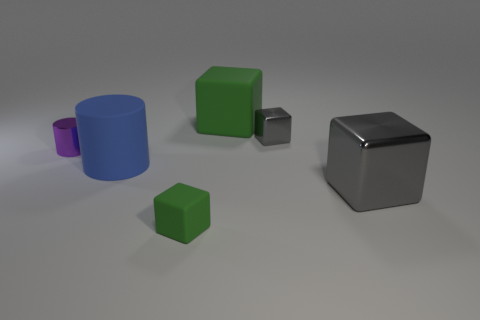Add 2 yellow rubber cylinders. How many objects exist? 8 Subtract all cylinders. How many objects are left? 4 Subtract all big purple cubes. Subtract all large green objects. How many objects are left? 5 Add 1 large blue rubber cylinders. How many large blue rubber cylinders are left? 2 Add 3 small green cylinders. How many small green cylinders exist? 3 Subtract 2 gray blocks. How many objects are left? 4 